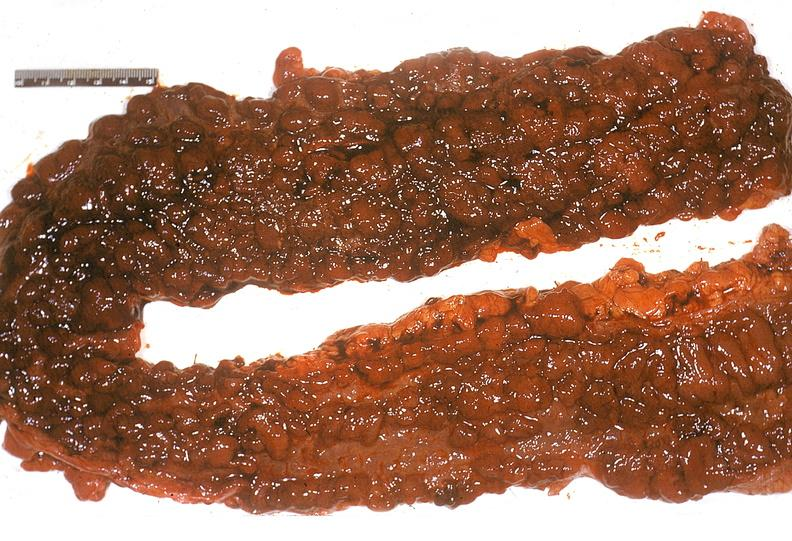does that show colon, ulcerative colitis?
Answer the question using a single word or phrase. No 